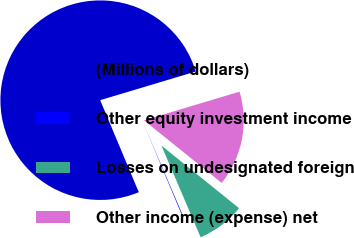<chart> <loc_0><loc_0><loc_500><loc_500><pie_chart><fcel>(Millions of dollars)<fcel>Other equity investment income<fcel>Losses on undesignated foreign<fcel>Other income (expense) net<nl><fcel>76.69%<fcel>0.11%<fcel>7.77%<fcel>15.43%<nl></chart> 